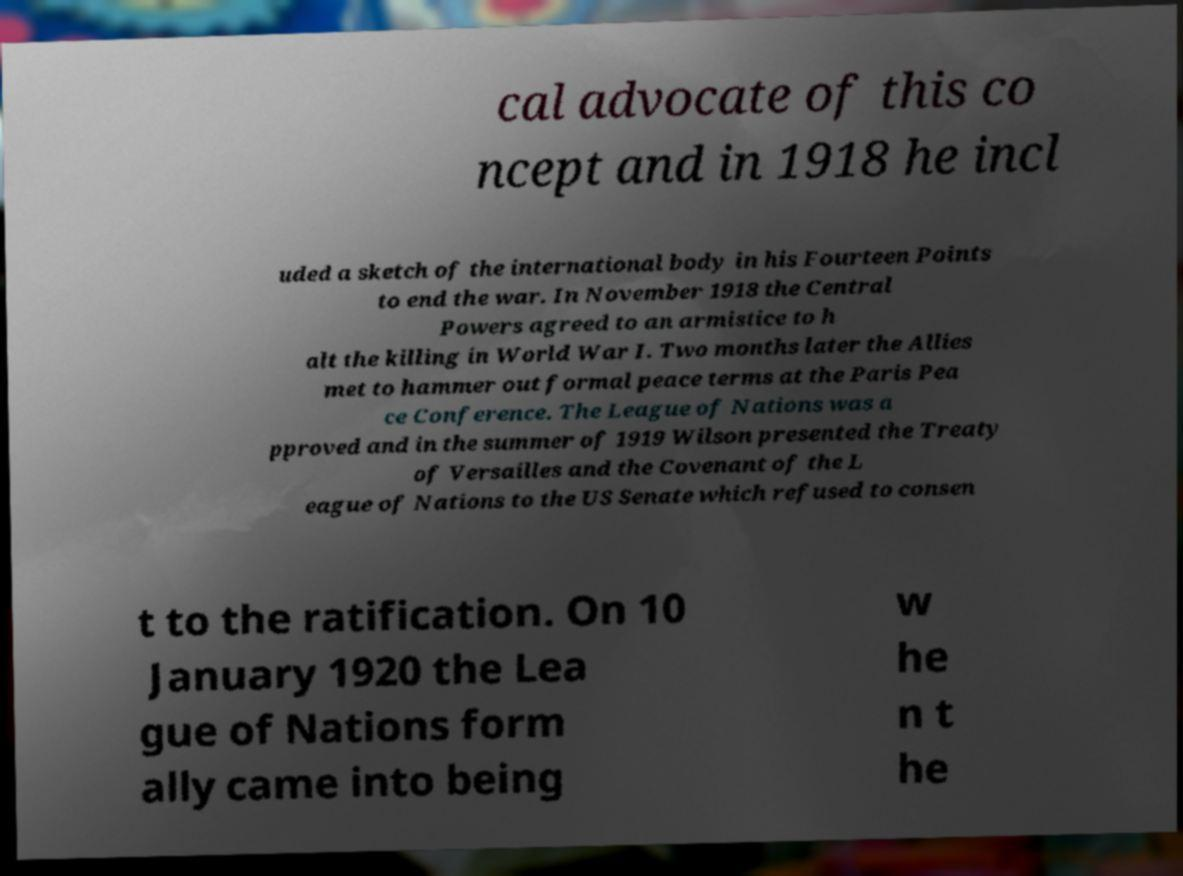Please identify and transcribe the text found in this image. cal advocate of this co ncept and in 1918 he incl uded a sketch of the international body in his Fourteen Points to end the war. In November 1918 the Central Powers agreed to an armistice to h alt the killing in World War I. Two months later the Allies met to hammer out formal peace terms at the Paris Pea ce Conference. The League of Nations was a pproved and in the summer of 1919 Wilson presented the Treaty of Versailles and the Covenant of the L eague of Nations to the US Senate which refused to consen t to the ratification. On 10 January 1920 the Lea gue of Nations form ally came into being w he n t he 